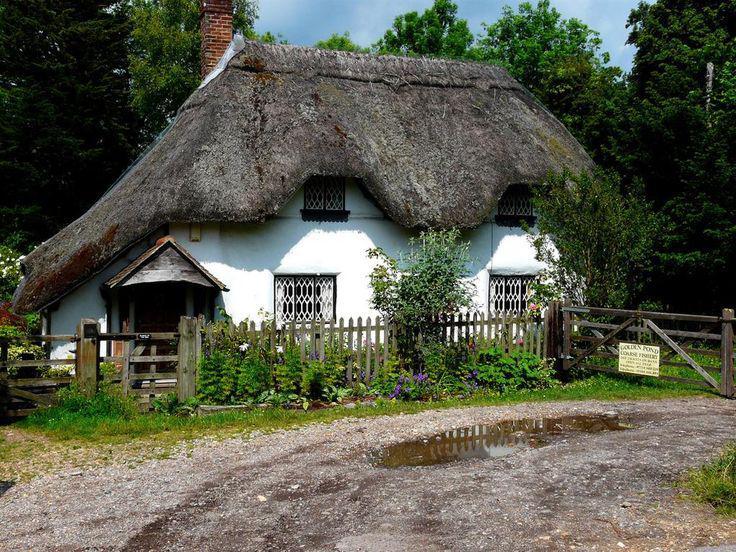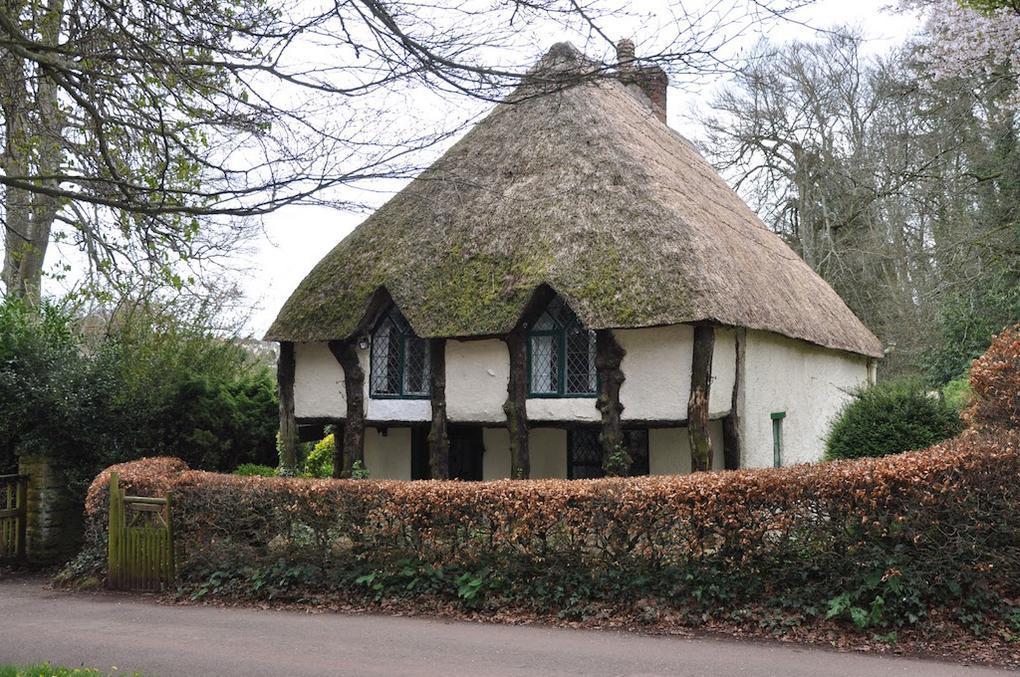The first image is the image on the left, the second image is the image on the right. Evaluate the accuracy of this statement regarding the images: "In at least one of the images you can see all the way through the house to the outside.". Is it true? Answer yes or no. No. 